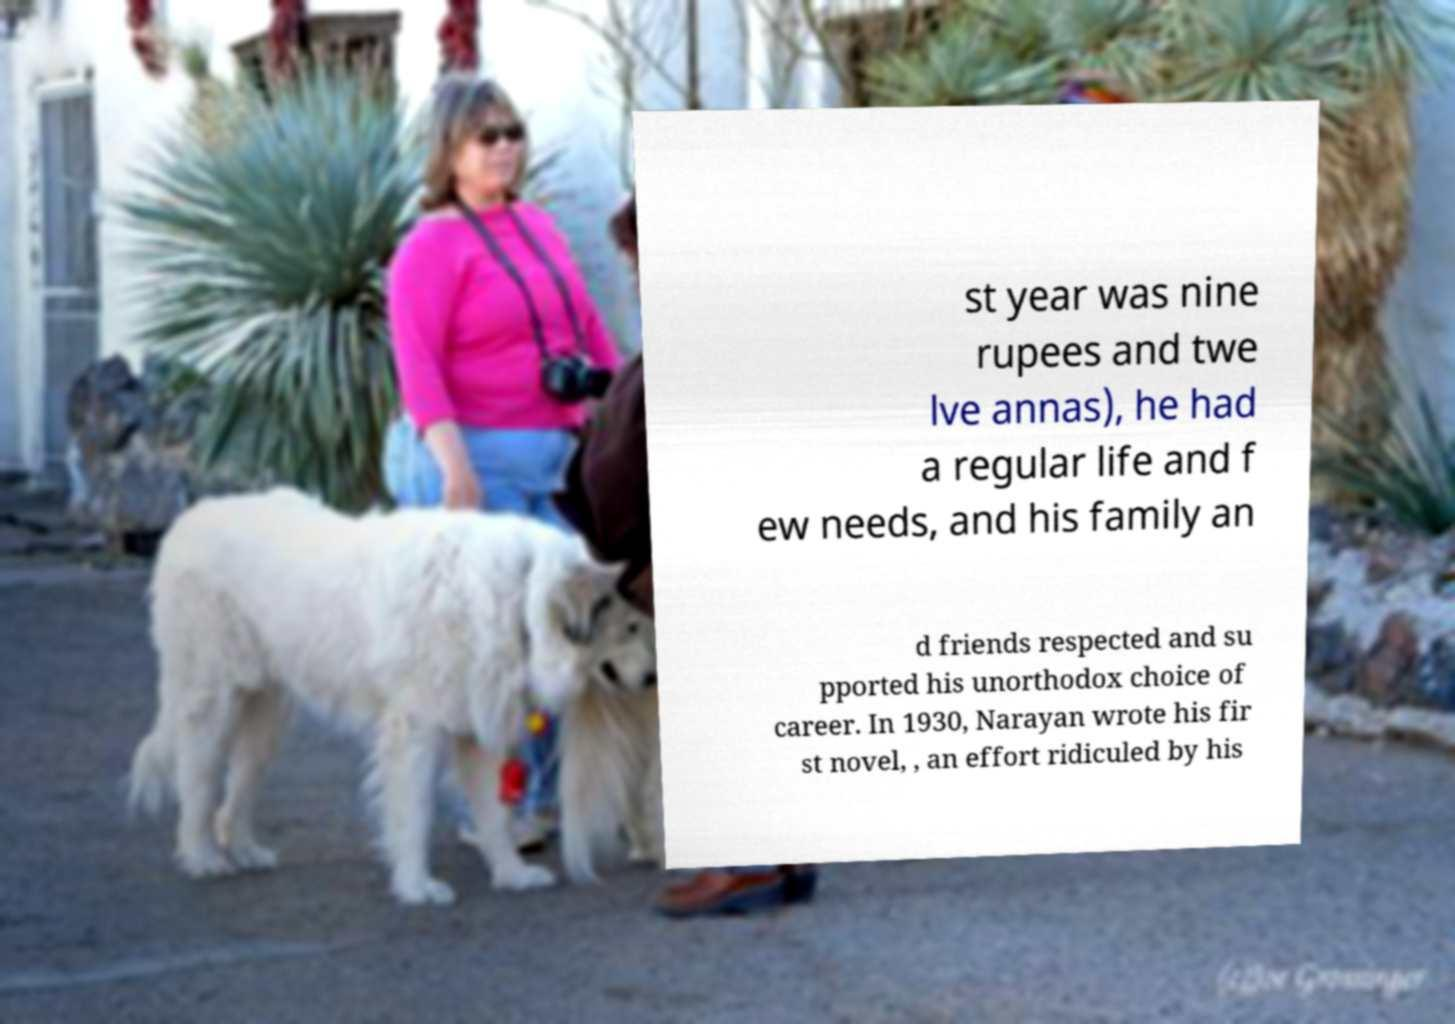For documentation purposes, I need the text within this image transcribed. Could you provide that? st year was nine rupees and twe lve annas), he had a regular life and f ew needs, and his family an d friends respected and su pported his unorthodox choice of career. In 1930, Narayan wrote his fir st novel, , an effort ridiculed by his 